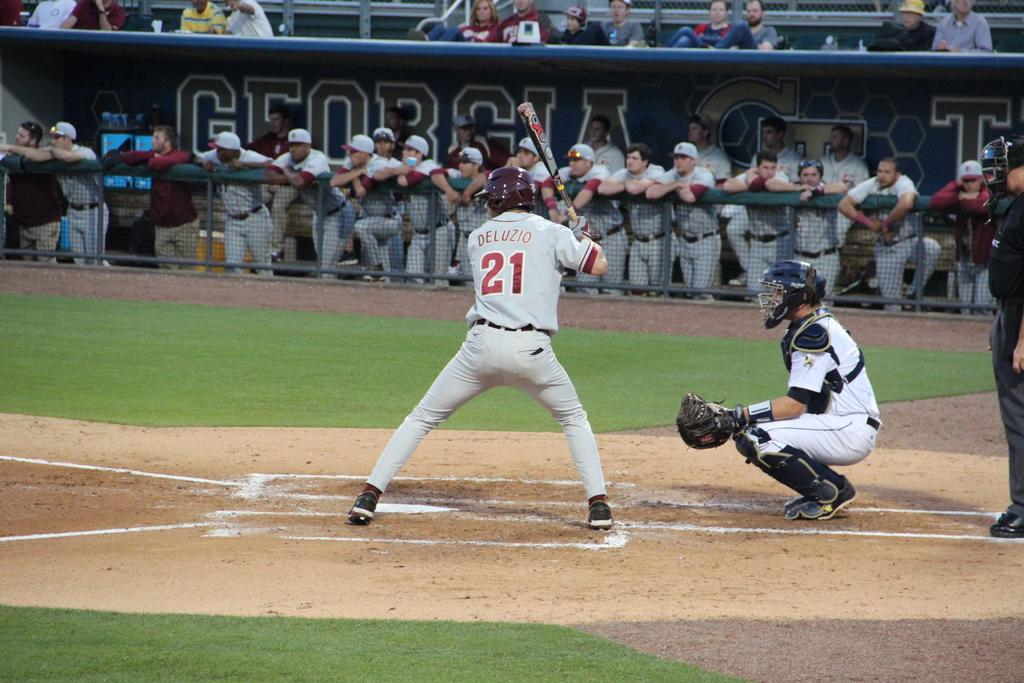Provide a one-sentence caption for the provided image. Baseball player wearing a number 21 on it. 